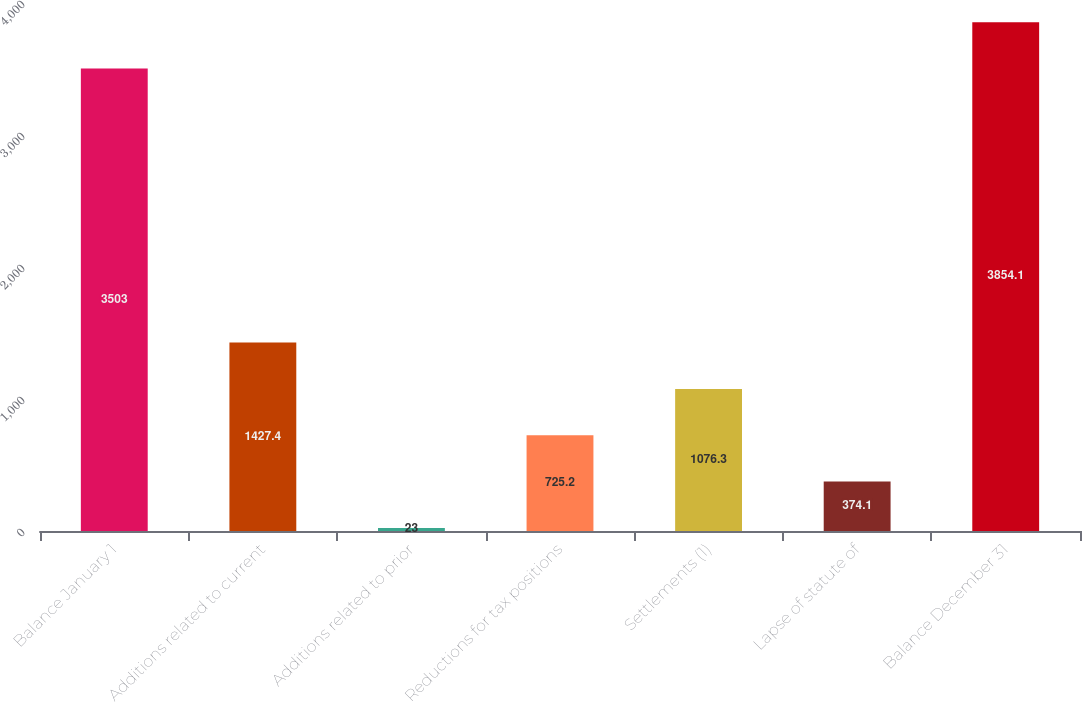Convert chart to OTSL. <chart><loc_0><loc_0><loc_500><loc_500><bar_chart><fcel>Balance January 1<fcel>Additions related to current<fcel>Additions related to prior<fcel>Reductions for tax positions<fcel>Settlements (1)<fcel>Lapse of statute of<fcel>Balance December 31<nl><fcel>3503<fcel>1427.4<fcel>23<fcel>725.2<fcel>1076.3<fcel>374.1<fcel>3854.1<nl></chart> 